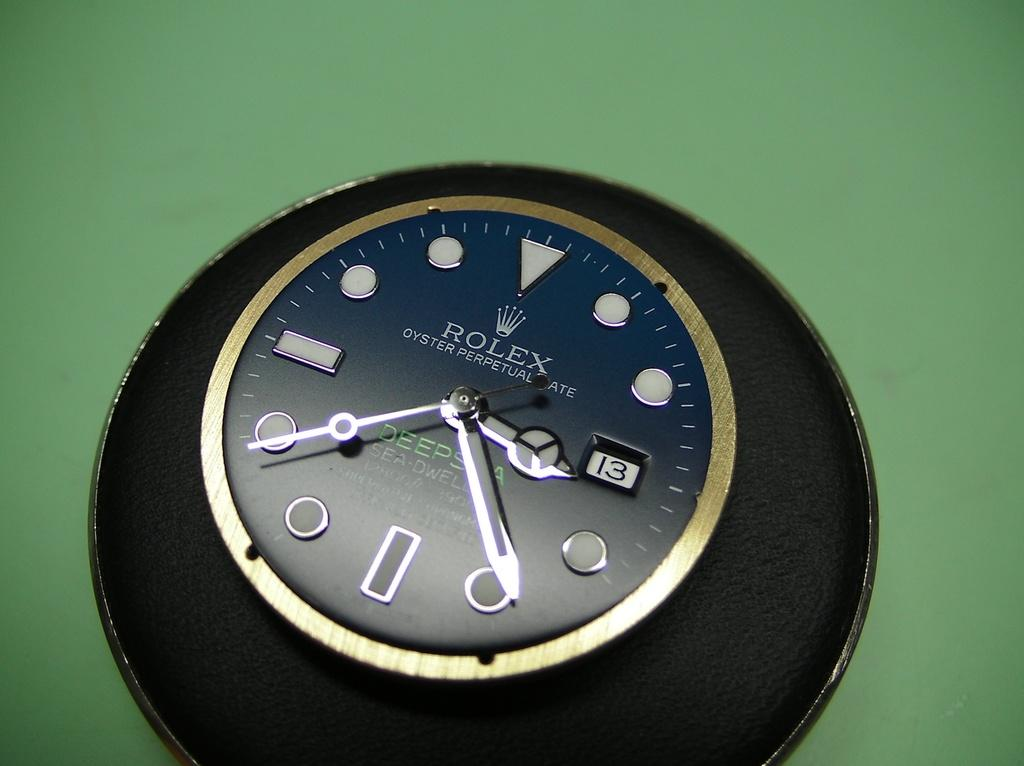<image>
Create a compact narrative representing the image presented. a rolex label on a clock that is black 